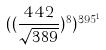Convert formula to latex. <formula><loc_0><loc_0><loc_500><loc_500>( ( \frac { 4 4 2 } { \sqrt { 3 8 9 } } ) ^ { 8 } ) ^ { 3 9 5 ^ { 1 } }</formula> 